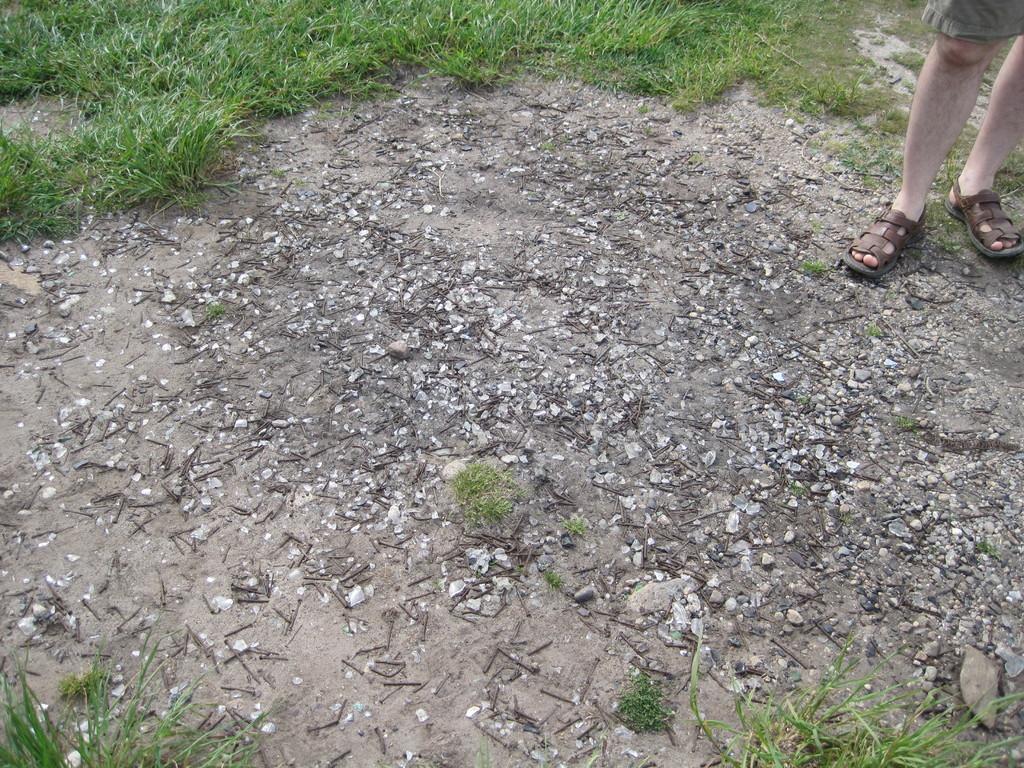Please provide a concise description of this image. In this image at the bottom there is sand and on the sand there are some iron nails, and on the right side there is one person standing and there is grass. 